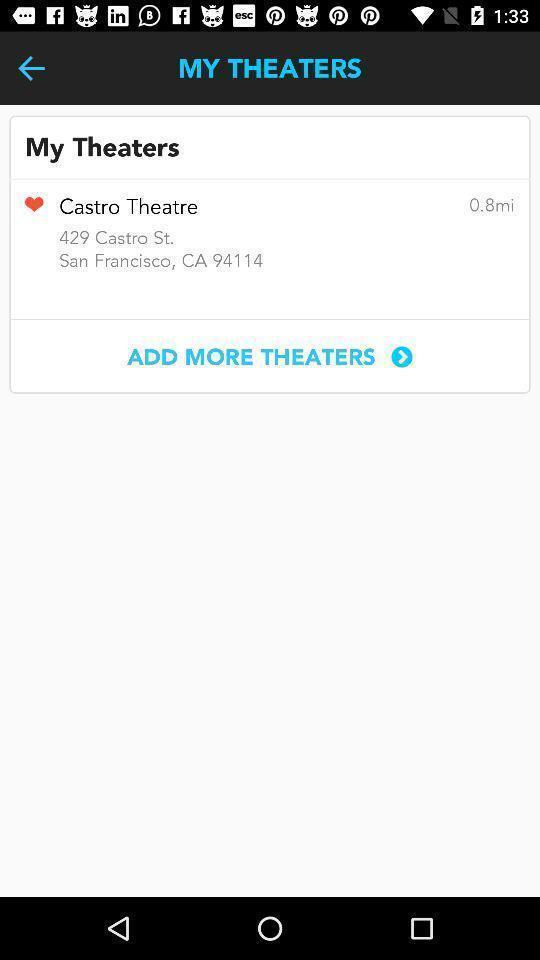Describe this image in words. Screen showing my theaters. 